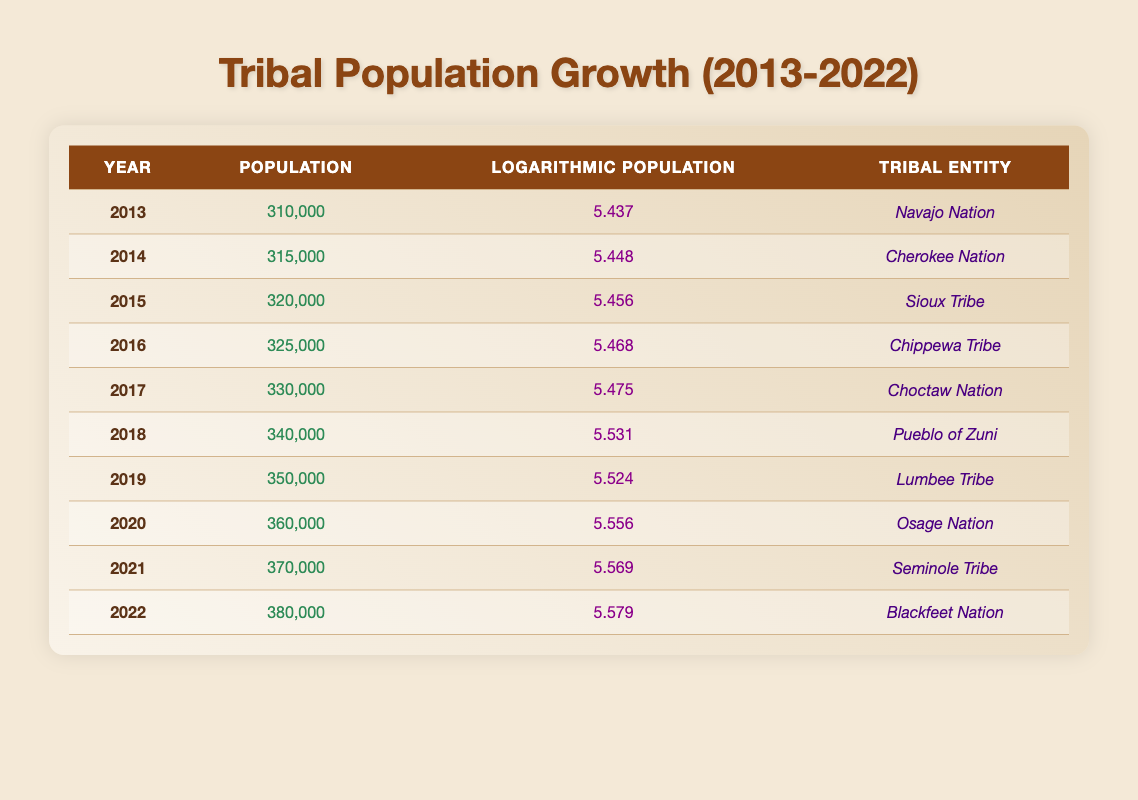What was the population in 2018? Looking at the row for the year 2018, the population is listed as 340,000.
Answer: 340,000 In which year did the population exceed 360,000 for the first time? The table shows that in 2020, the population reached 360,000. Thus, 2020 is the first year when the population exceeded 360,000.
Answer: 2020 What is the total population increase from 2013 to 2022? The population in 2013 was 310,000 and in 2022 it was 380,000. The total increase is 380,000 - 310,000, which equals 70,000.
Answer: 70,000 What was the average population from 2014 to 2019? The populations from 2014 to 2019 are 315,000, 320,000, 325,000, 330,000, 340,000, and 350,000. The total sum is 315,000 + 320,000 + 325,000 + 330,000 + 340,000 + 350,000 = 1,980,000. There are 6 years, so the average is 1,980,000 / 6 = 330,000.
Answer: 330,000 Is the logarithmic population value for 2021 greater than that of 2019? For 2021, the logarithmic population is 5.569, and for 2019 it is 5.524. Since 5.569 is greater than 5.524, the statement is true.
Answer: Yes Which year saw the largest year-over-year population growth? To determine year-over-year growth, subtract each year's population from the subsequent year's population. The largest increase is from 2017 (330,000) to 2018 (340,000), which is 10,000. Thus, 2018 saw the largest year-over-year growth compared to 2017.
Answer: 2018 